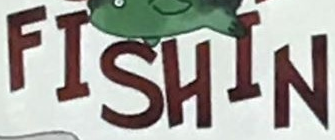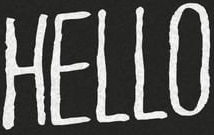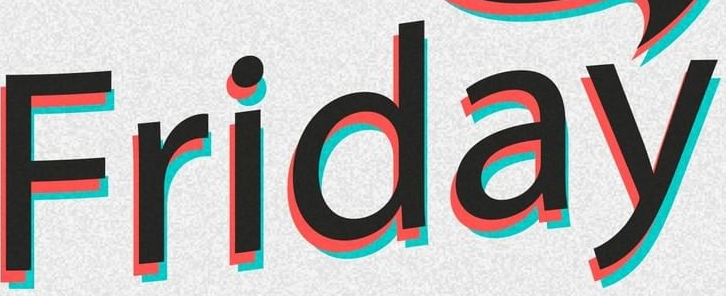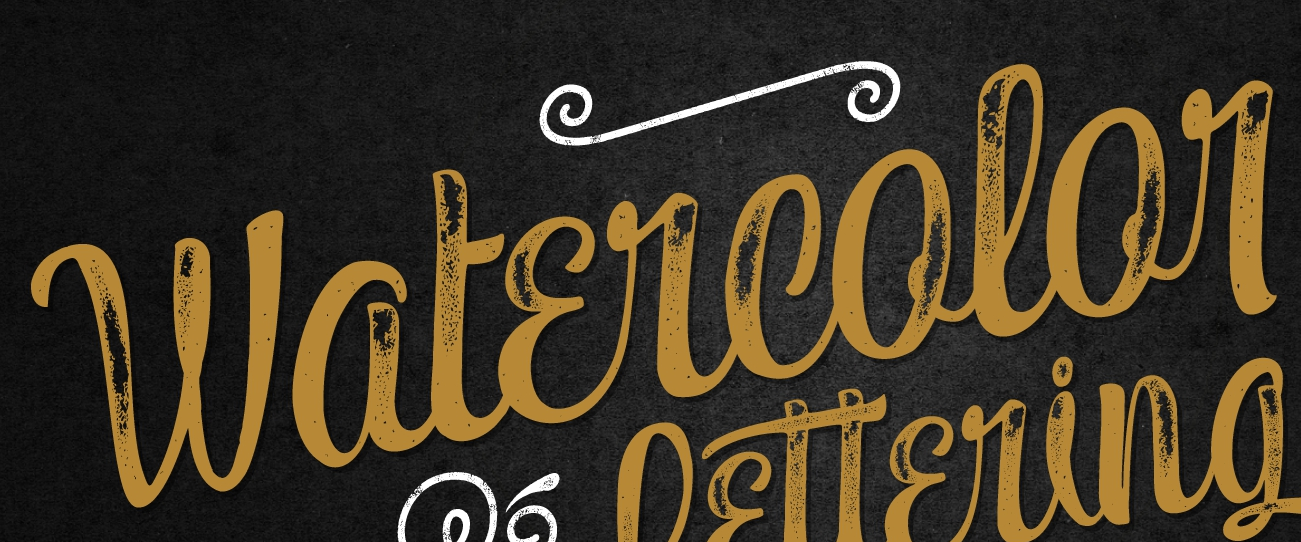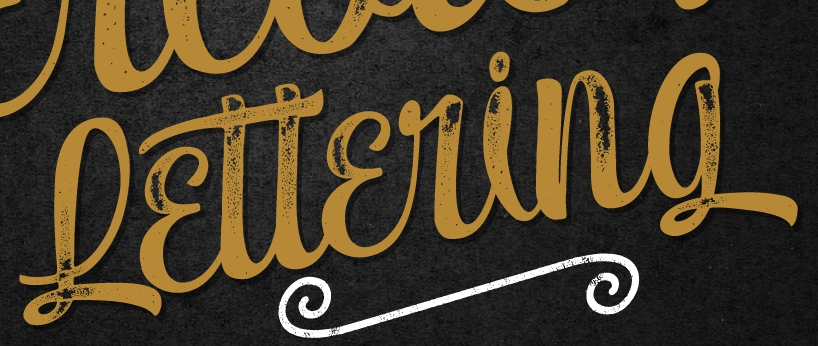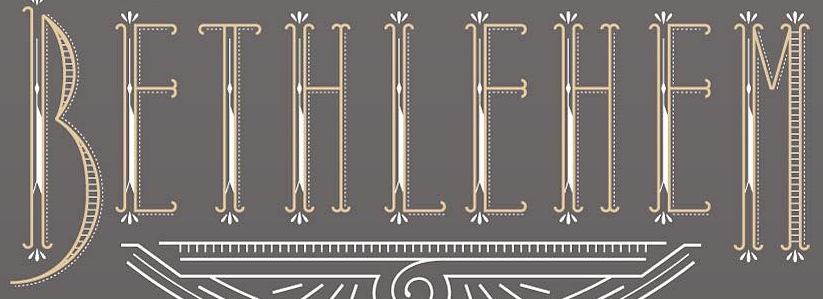Transcribe the words shown in these images in order, separated by a semicolon. FISHIN; HELLO; Friday; Watɛrcolor; Lɛttɛring; BEIHIEHEM 